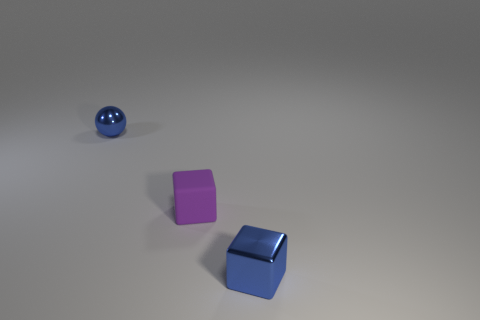Add 1 matte cubes. How many objects exist? 4 Subtract all purple cubes. How many cubes are left? 1 Subtract 0 gray spheres. How many objects are left? 3 Subtract all balls. How many objects are left? 2 Subtract all blue cubes. Subtract all purple spheres. How many cubes are left? 1 Subtract all green cubes. How many green spheres are left? 0 Subtract all big cyan metal cubes. Subtract all tiny purple things. How many objects are left? 2 Add 3 small blue metal things. How many small blue metal things are left? 5 Add 1 brown matte spheres. How many brown matte spheres exist? 1 